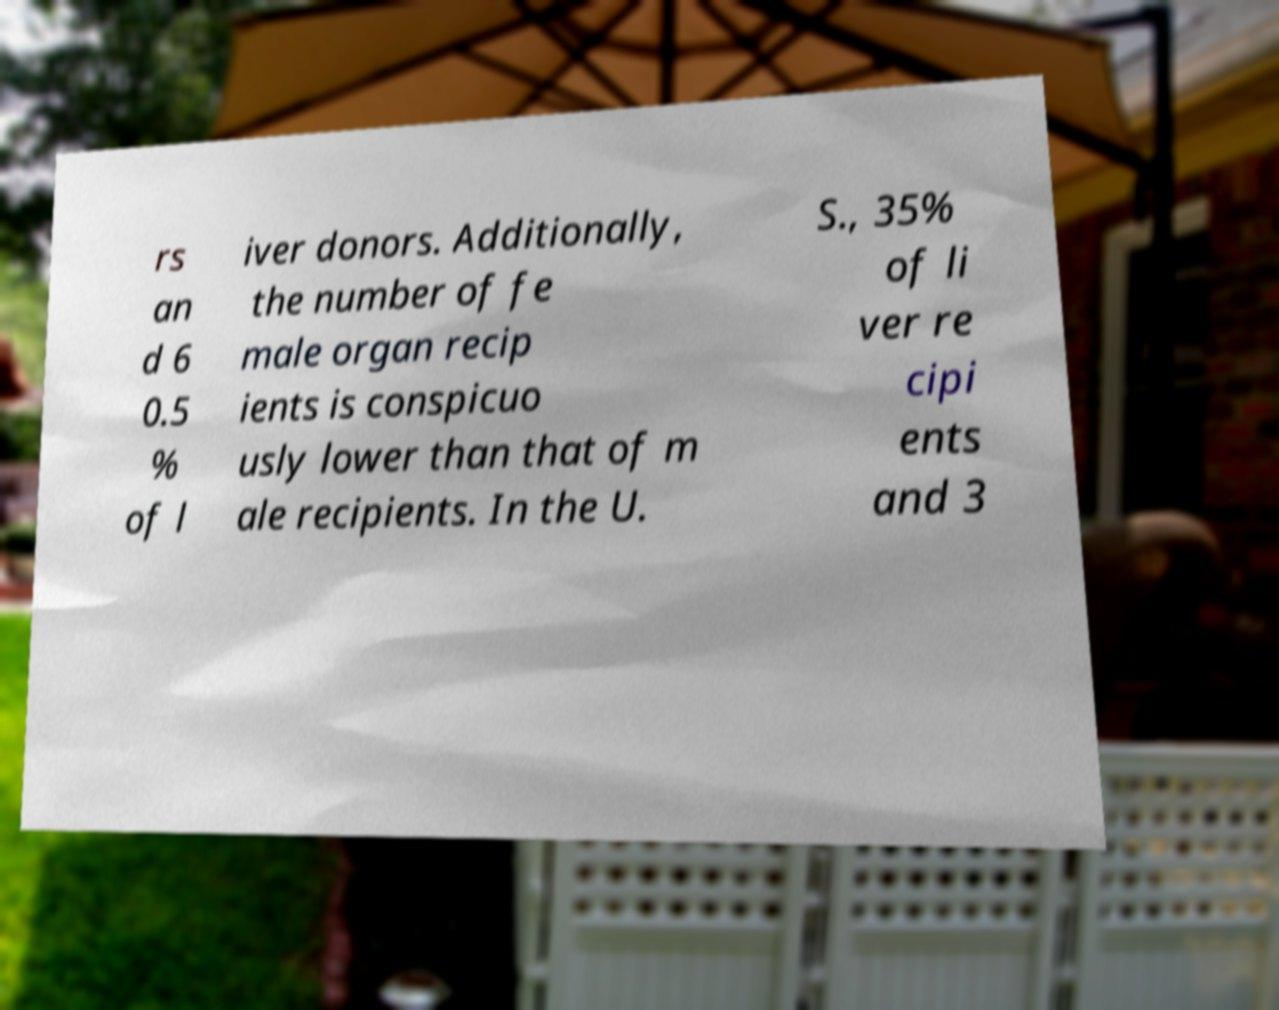Please identify and transcribe the text found in this image. rs an d 6 0.5 % of l iver donors. Additionally, the number of fe male organ recip ients is conspicuo usly lower than that of m ale recipients. In the U. S., 35% of li ver re cipi ents and 3 